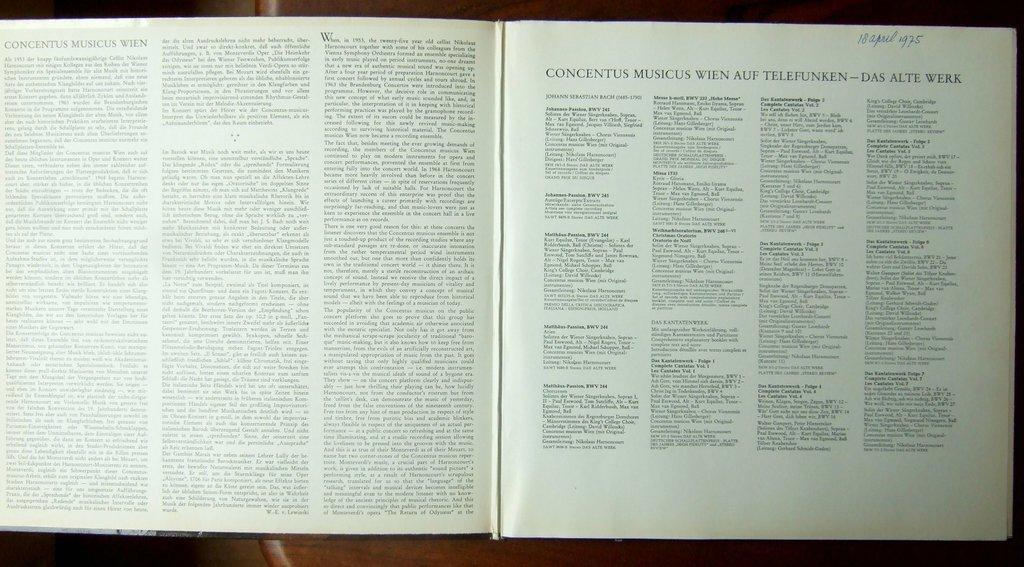Provide a one-sentence caption for the provided image. Concentus Musicus Wien is the title of the chapter of this open book. 